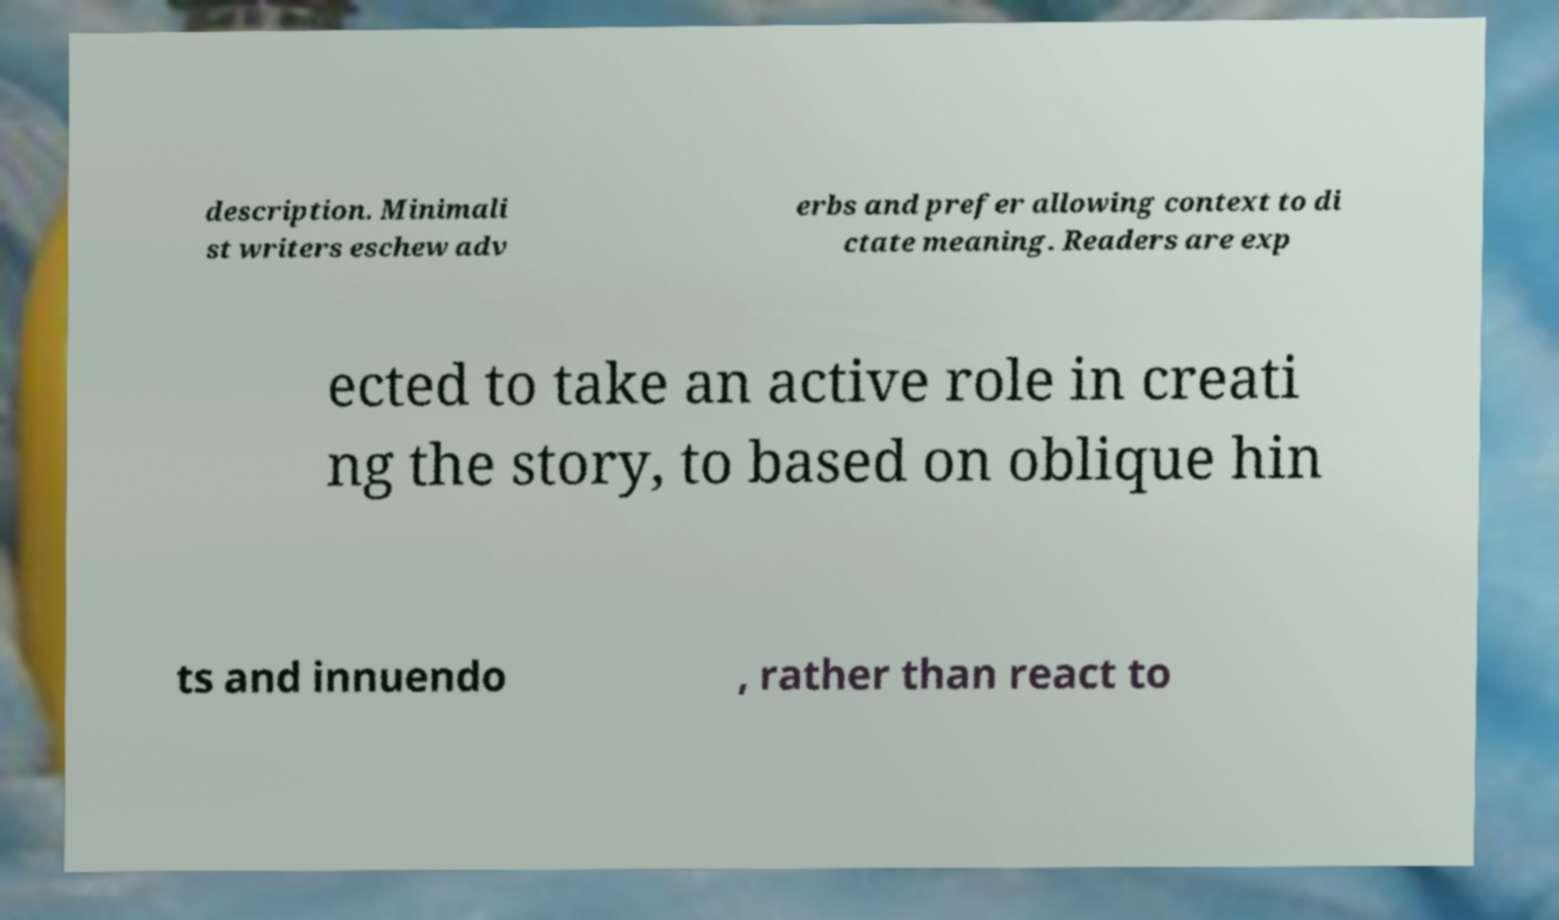For documentation purposes, I need the text within this image transcribed. Could you provide that? description. Minimali st writers eschew adv erbs and prefer allowing context to di ctate meaning. Readers are exp ected to take an active role in creati ng the story, to based on oblique hin ts and innuendo , rather than react to 